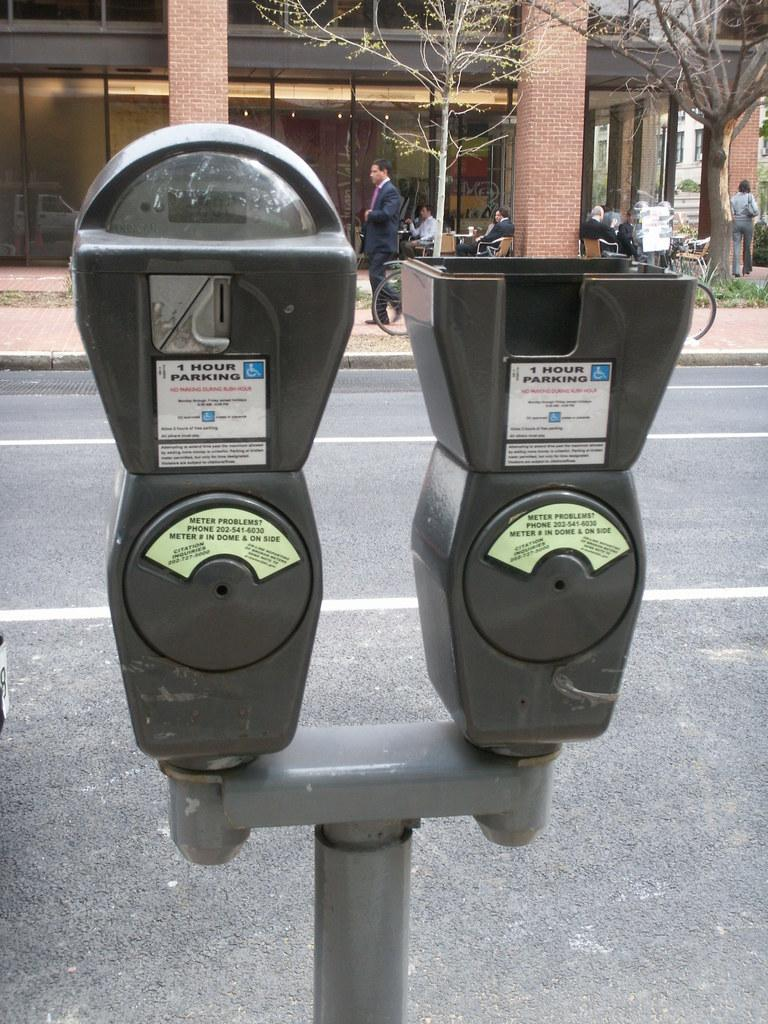Provide a one-sentence caption for the provided image. Meter that have one hour parking and a handicapped sign. 